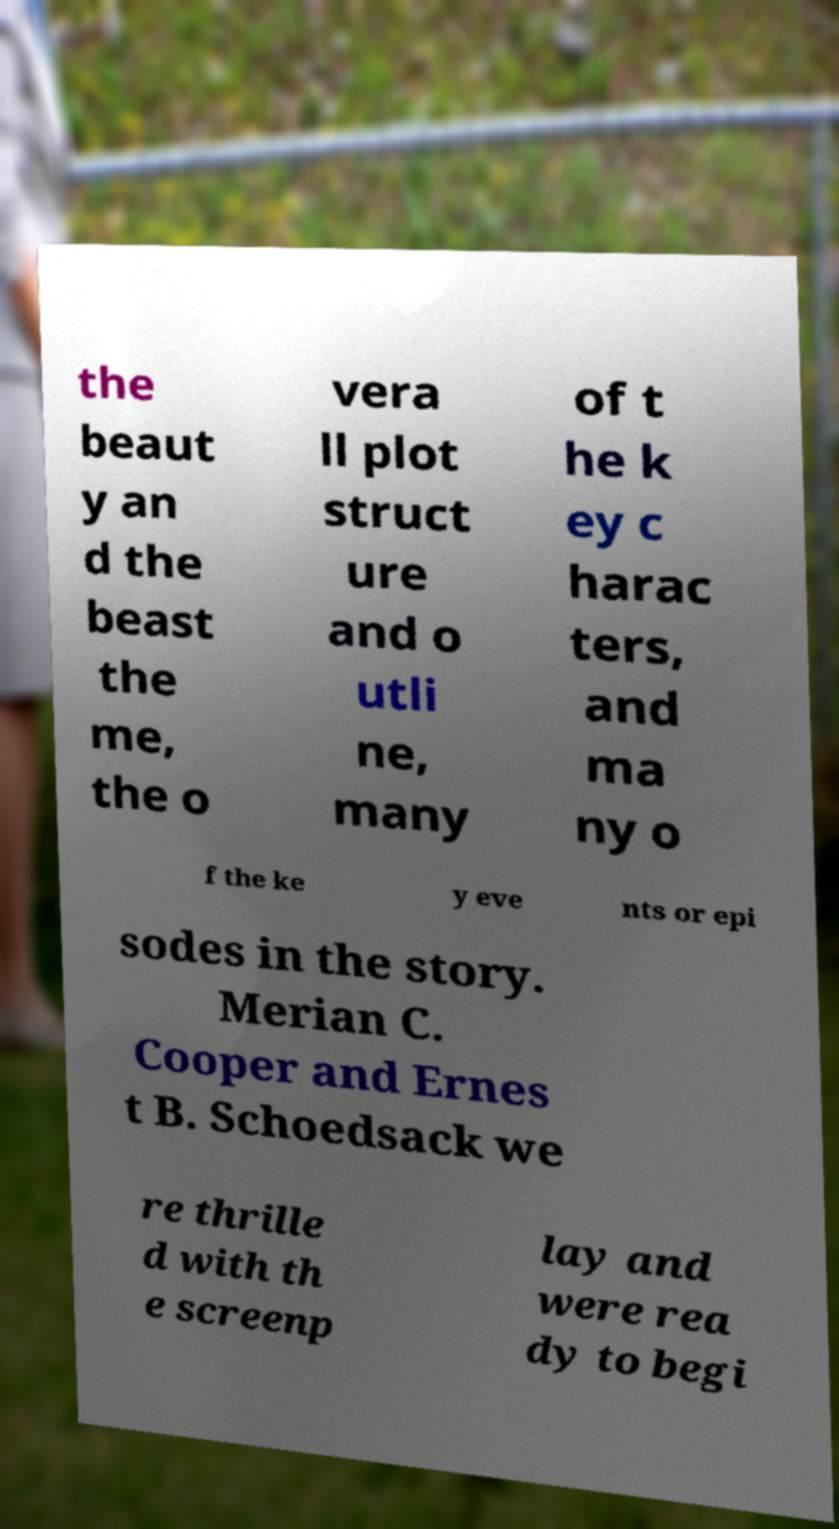Can you read and provide the text displayed in the image?This photo seems to have some interesting text. Can you extract and type it out for me? the beaut y an d the beast the me, the o vera ll plot struct ure and o utli ne, many of t he k ey c harac ters, and ma ny o f the ke y eve nts or epi sodes in the story. Merian C. Cooper and Ernes t B. Schoedsack we re thrille d with th e screenp lay and were rea dy to begi 